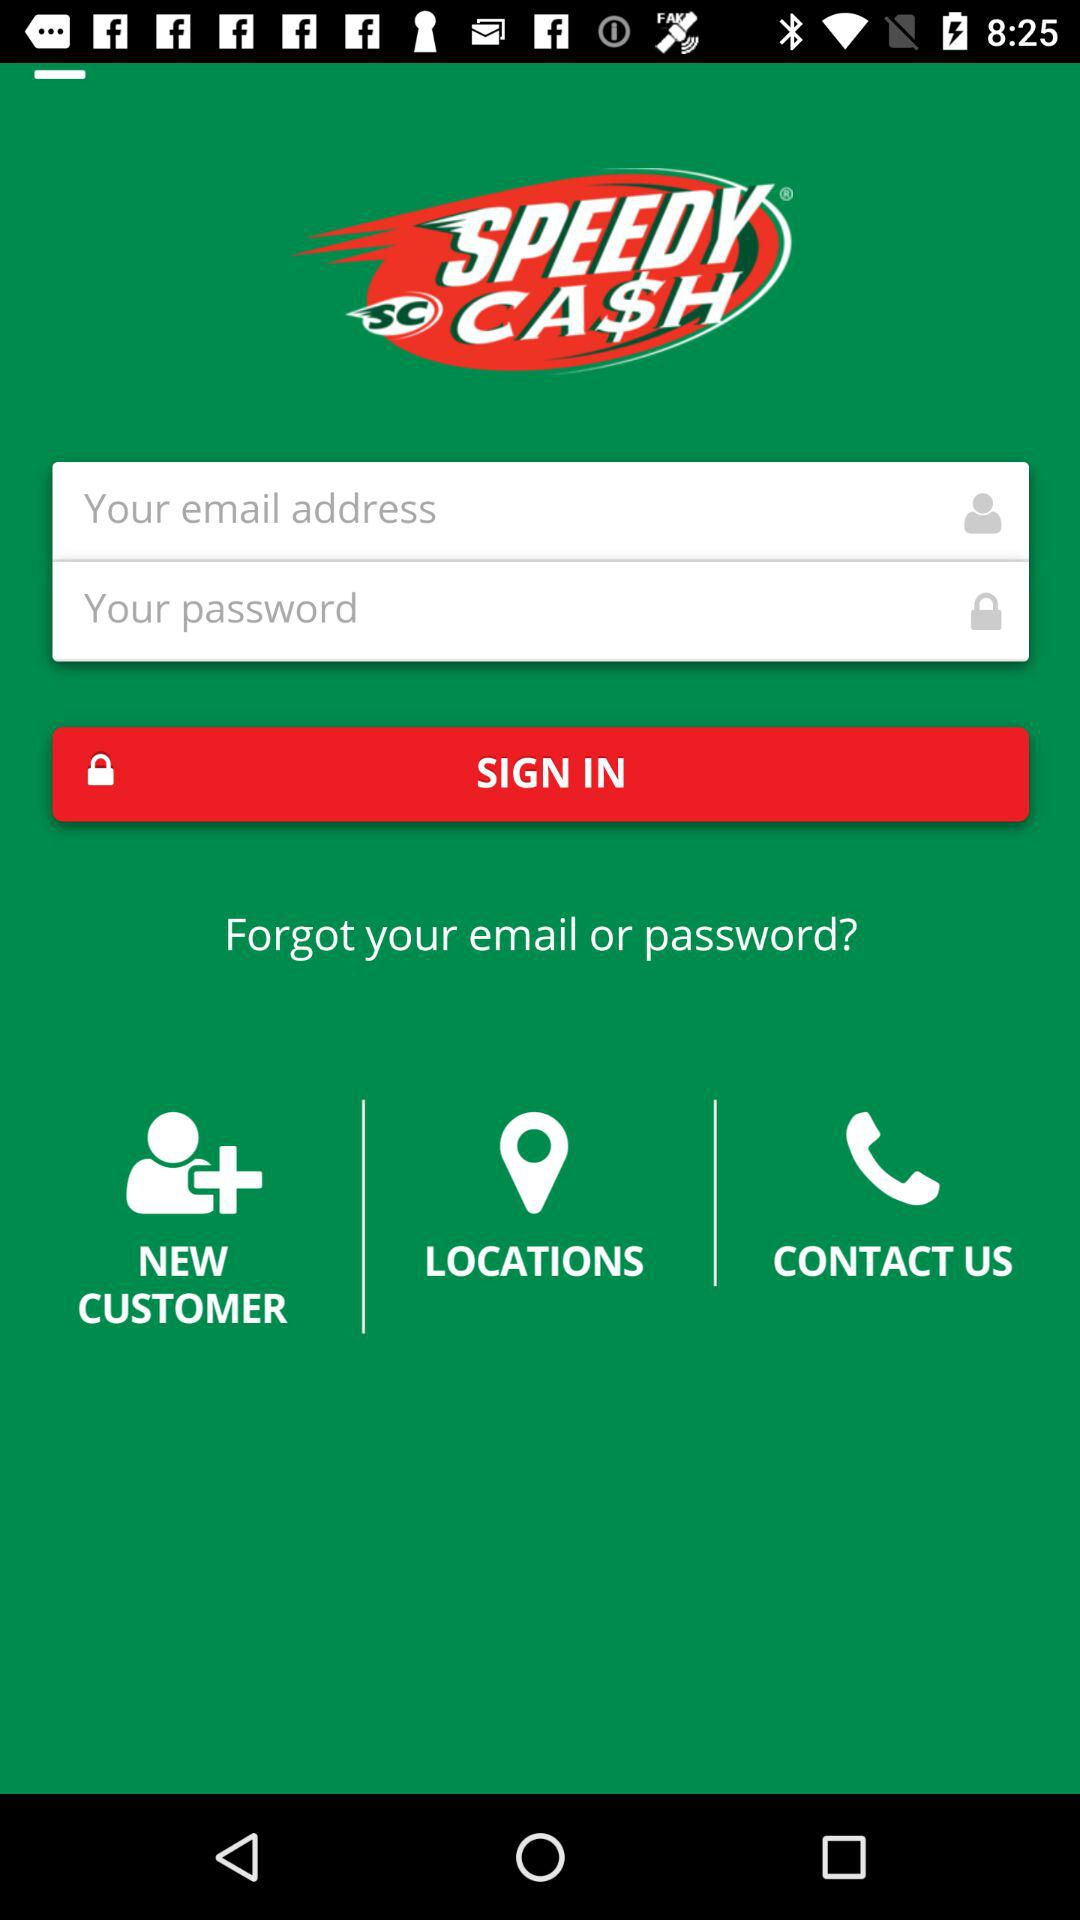Can we reset email address?
When the provided information is insufficient, respond with <no answer>. <no answer> 